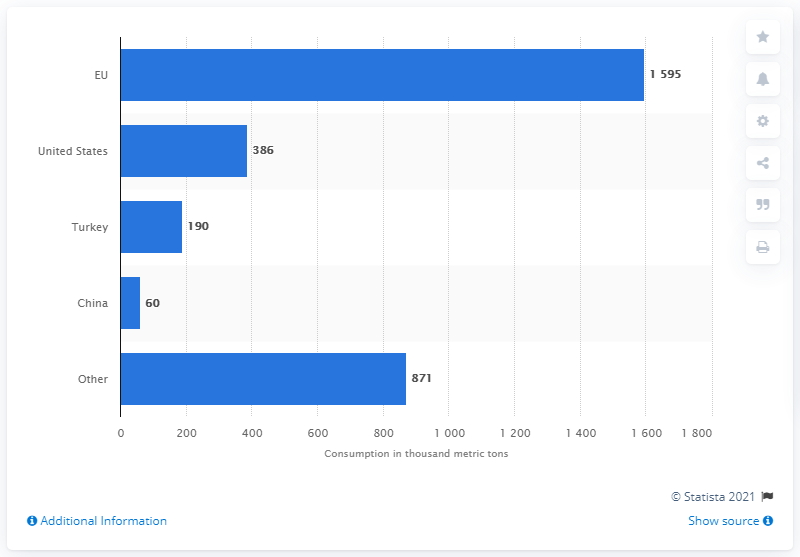Give some essential details in this illustration. Turkey was the third largest consumer of olive oil in 2020/2021. 